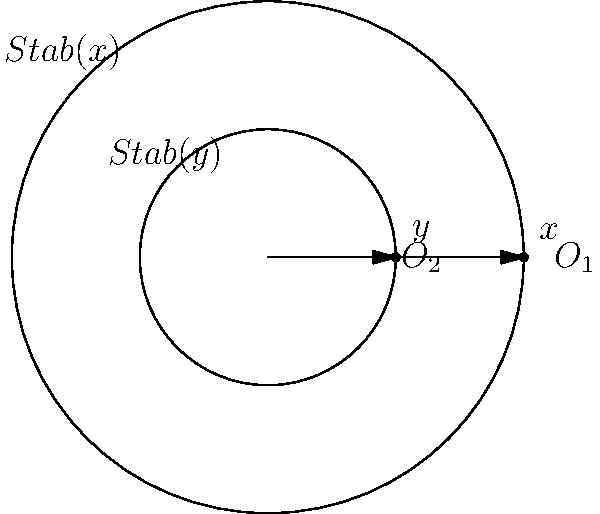Consider a group $G$ acting on a set $X$. The orbit-stabilizer diagram above represents the action of $G$ on two elements $x$ and $y$ in $X$. Given that $|G| = 24$, $|O_1| = 8$, and $|O_2| = 6$, determine $|Stab(x) \cap Stab(y)|$. Let's approach this step-by-step:

1) First, recall the Orbit-Stabilizer Theorem: For any $x \in X$, $|G| = |O(x)| \cdot |Stab(x)|$.

2) For $x$:
   $|G| = |O_1| \cdot |Stab(x)|$
   $24 = 8 \cdot |Stab(x)|$
   $|Stab(x)| = 3$

3) For $y$:
   $|G| = |O_2| \cdot |Stab(y)|$
   $24 = 6 \cdot |Stab(y)|$
   $|Stab(y)| = 4$

4) Now, let's consider $Stab(x) \cap Stab(y)$. We can use the principle of inclusion-exclusion:

   $|Stab(x) \cup Stab(y)| = |Stab(x)| + |Stab(y)| - |Stab(x) \cap Stab(y)|$

5) We know that $Stab(x) \cup Stab(y)$ is a subgroup of $G$. By Lagrange's Theorem, its order must divide $|G| = 24$. The only possibility that satisfies this and is less than or equal to $|Stab(x)| + |Stab(y)| = 3 + 4 = 7$ is 6.

6) Therefore:
   $6 = 3 + 4 - |Stab(x) \cap Stab(y)|$
   $|Stab(x) \cap Stab(y)| = 1$

Thus, we have determined that $|Stab(x) \cap Stab(y)| = 1$.
Answer: 1 